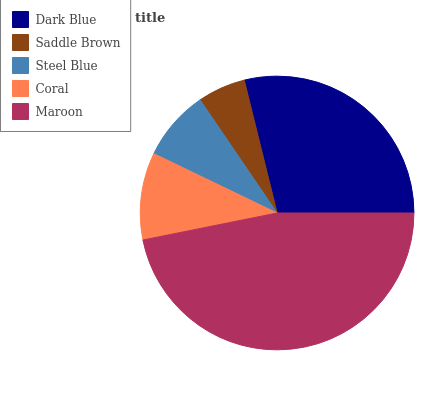Is Saddle Brown the minimum?
Answer yes or no. Yes. Is Maroon the maximum?
Answer yes or no. Yes. Is Steel Blue the minimum?
Answer yes or no. No. Is Steel Blue the maximum?
Answer yes or no. No. Is Steel Blue greater than Saddle Brown?
Answer yes or no. Yes. Is Saddle Brown less than Steel Blue?
Answer yes or no. Yes. Is Saddle Brown greater than Steel Blue?
Answer yes or no. No. Is Steel Blue less than Saddle Brown?
Answer yes or no. No. Is Coral the high median?
Answer yes or no. Yes. Is Coral the low median?
Answer yes or no. Yes. Is Dark Blue the high median?
Answer yes or no. No. Is Saddle Brown the low median?
Answer yes or no. No. 